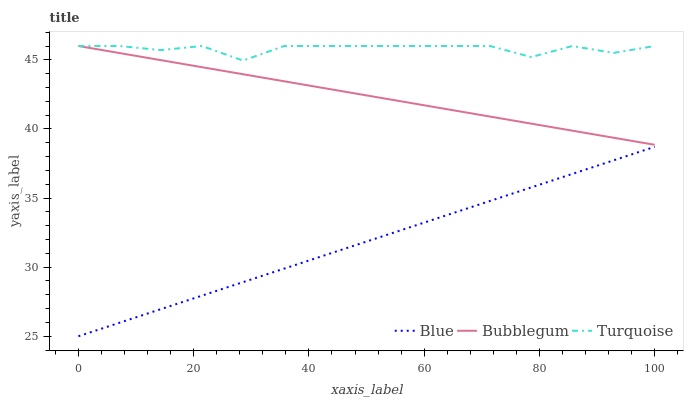Does Blue have the minimum area under the curve?
Answer yes or no. Yes. Does Turquoise have the maximum area under the curve?
Answer yes or no. Yes. Does Bubblegum have the minimum area under the curve?
Answer yes or no. No. Does Bubblegum have the maximum area under the curve?
Answer yes or no. No. Is Blue the smoothest?
Answer yes or no. Yes. Is Turquoise the roughest?
Answer yes or no. Yes. Is Bubblegum the smoothest?
Answer yes or no. No. Is Bubblegum the roughest?
Answer yes or no. No. Does Blue have the lowest value?
Answer yes or no. Yes. Does Bubblegum have the lowest value?
Answer yes or no. No. Does Bubblegum have the highest value?
Answer yes or no. Yes. Is Blue less than Bubblegum?
Answer yes or no. Yes. Is Bubblegum greater than Blue?
Answer yes or no. Yes. Does Bubblegum intersect Turquoise?
Answer yes or no. Yes. Is Bubblegum less than Turquoise?
Answer yes or no. No. Is Bubblegum greater than Turquoise?
Answer yes or no. No. Does Blue intersect Bubblegum?
Answer yes or no. No. 